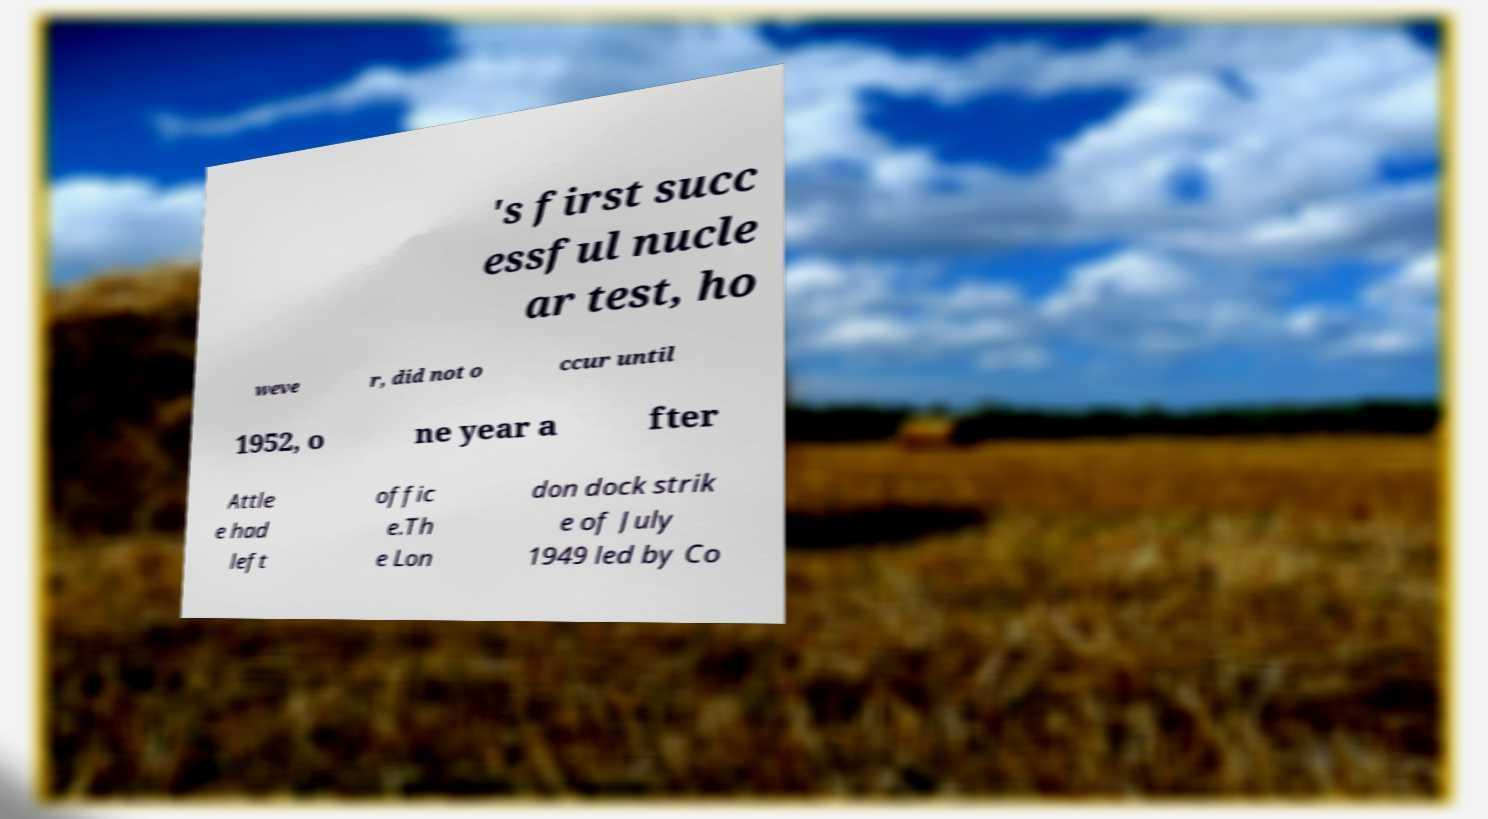Could you extract and type out the text from this image? 's first succ essful nucle ar test, ho weve r, did not o ccur until 1952, o ne year a fter Attle e had left offic e.Th e Lon don dock strik e of July 1949 led by Co 